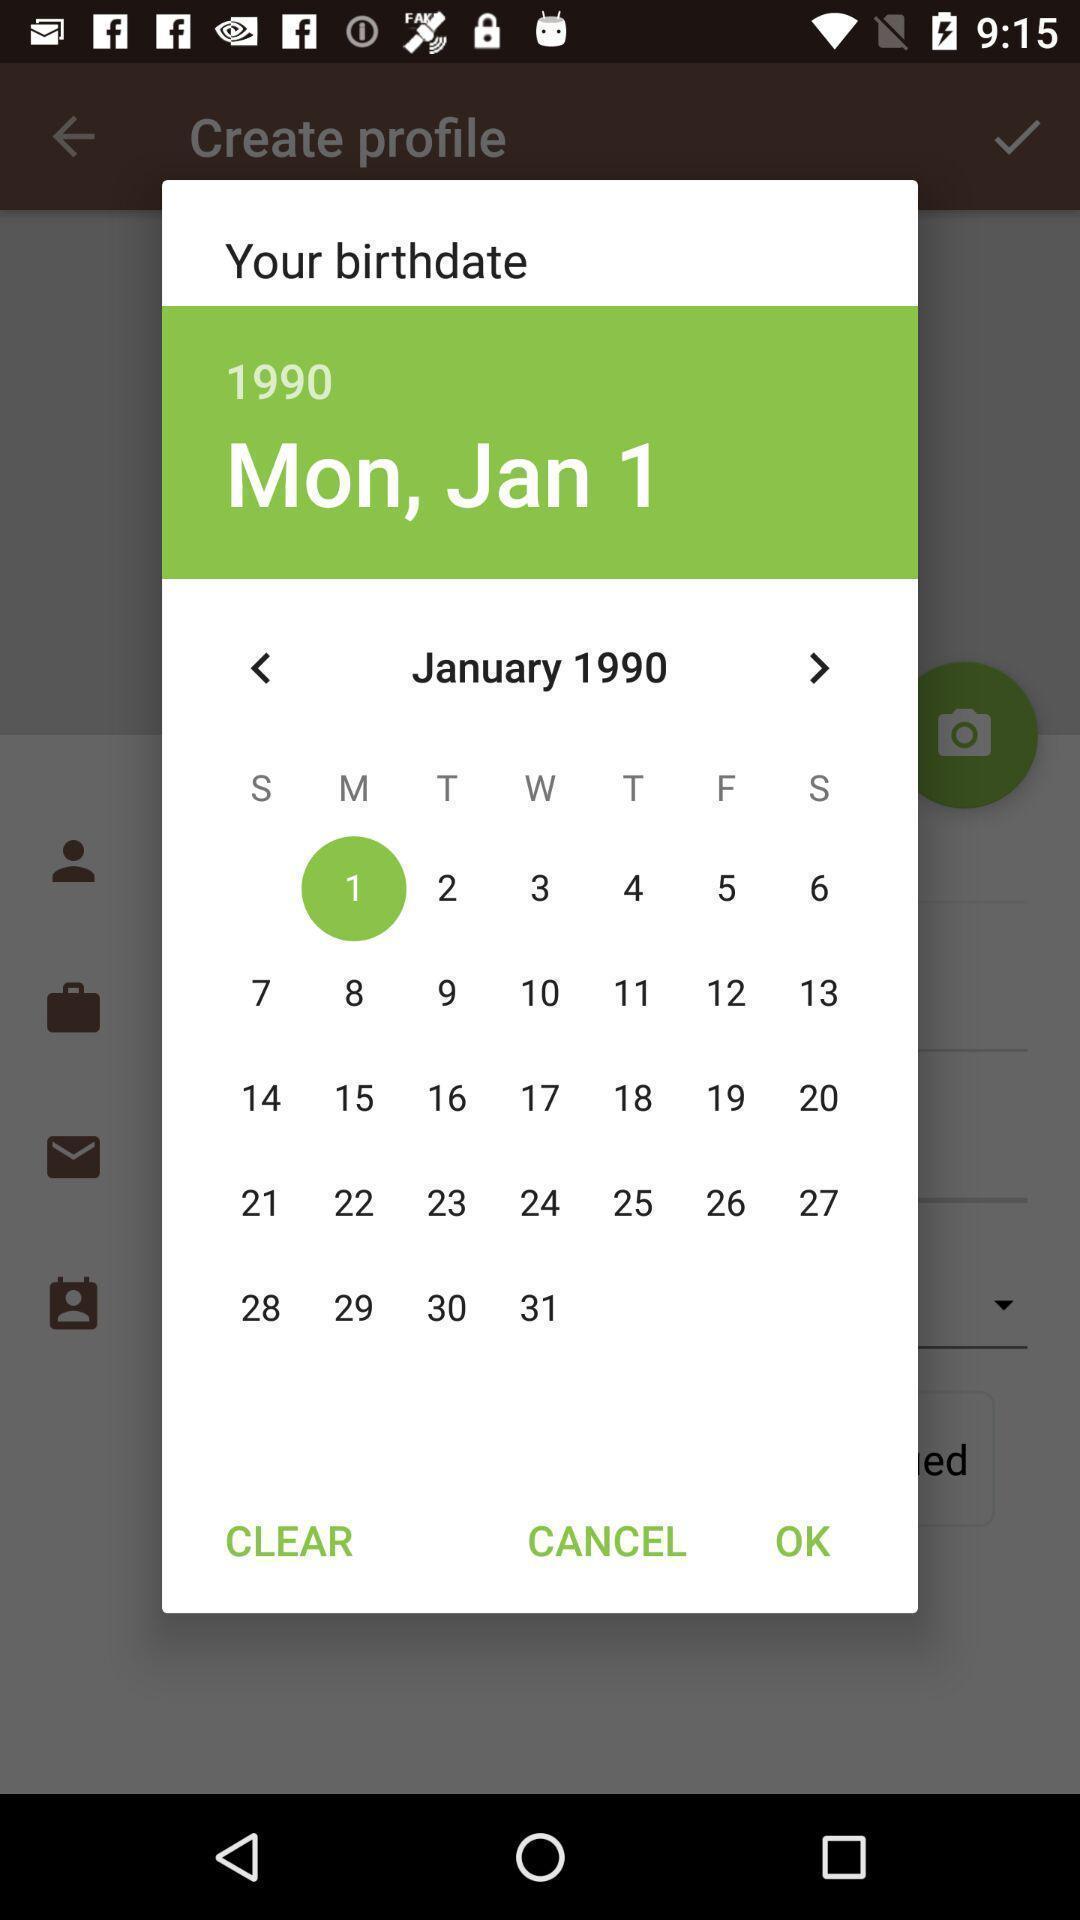Explain the elements present in this screenshot. Pop-up showing calendar of a month. 